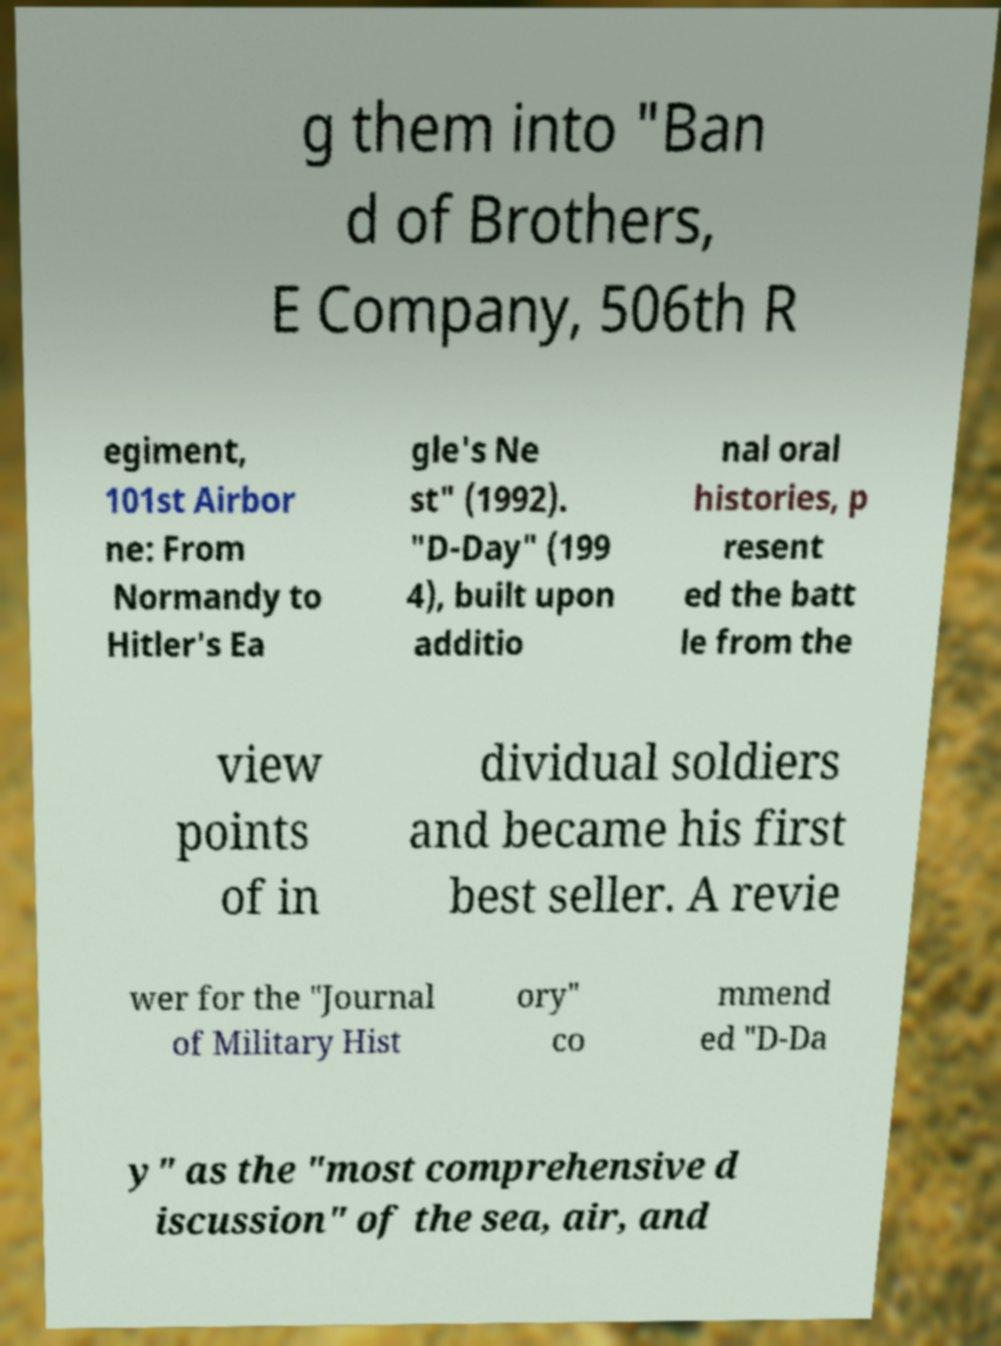Please read and relay the text visible in this image. What does it say? g them into "Ban d of Brothers, E Company, 506th R egiment, 101st Airbor ne: From Normandy to Hitler's Ea gle's Ne st" (1992). "D-Day" (199 4), built upon additio nal oral histories, p resent ed the batt le from the view points of in dividual soldiers and became his first best seller. A revie wer for the "Journal of Military Hist ory" co mmend ed "D-Da y" as the "most comprehensive d iscussion" of the sea, air, and 